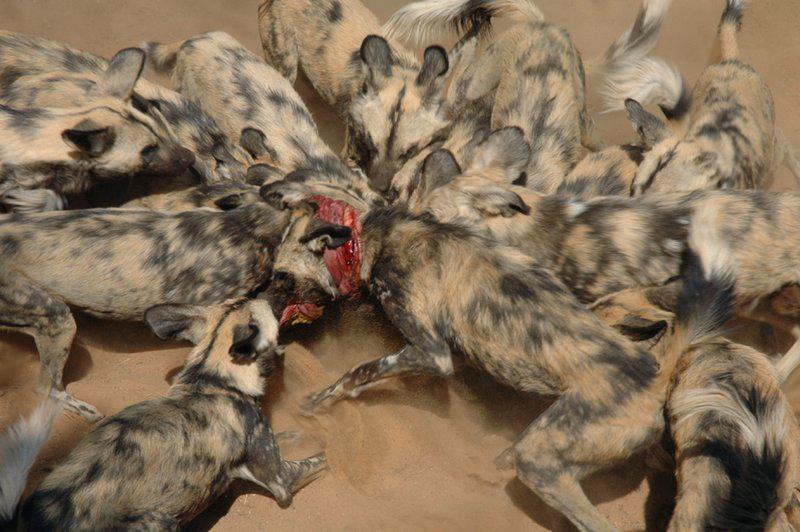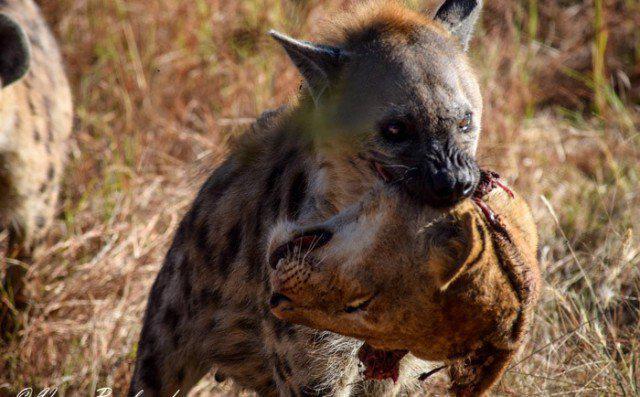The first image is the image on the left, the second image is the image on the right. Examine the images to the left and right. Is the description "A hyena is carrying off the head of its prey in one of the images." accurate? Answer yes or no. Yes. The first image is the image on the left, the second image is the image on the right. Evaluate the accuracy of this statement regarding the images: "At least one animal is carrying a piece of its prey in its mouth.". Is it true? Answer yes or no. Yes. 